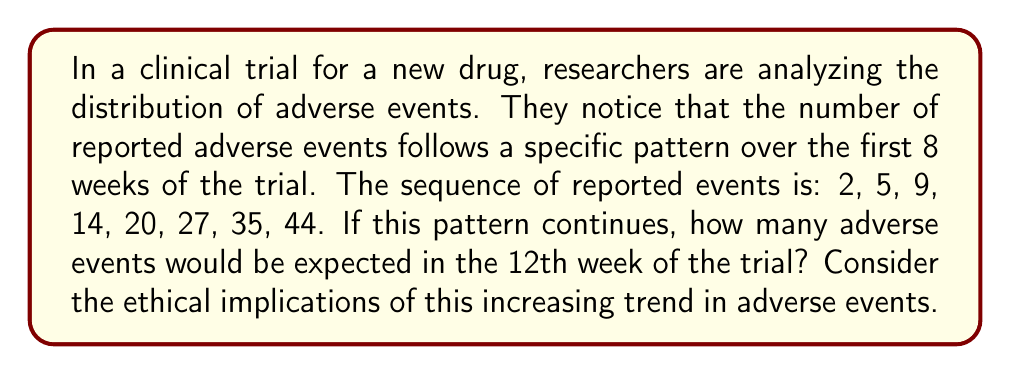Solve this math problem. To solve this problem, we need to analyze the sequence and identify the pattern:

1. First, let's calculate the differences between consecutive terms:
   $5 - 2 = 3$
   $9 - 5 = 4$
   $14 - 9 = 5$
   $20 - 14 = 6$
   $27 - 20 = 7$
   $35 - 27 = 8$
   $44 - 35 = 9$

2. We observe that the differences form an arithmetic sequence: 3, 4, 5, 6, 7, 8, 9
   The common difference of this arithmetic sequence is 1.

3. This indicates that the original sequence is a quadratic sequence, where the second differences are constant.

4. The general formula for a quadratic sequence is:
   $a_n = \frac{1}{2}n^2 + bn + c$, where $n$ is the term number.

5. We can use the first term to find $c$:
   $2 = \frac{1}{2}(1)^2 + b(1) + c$
   $2 = \frac{1}{2} + b + c$

6. Using the second term:
   $5 = \frac{1}{2}(2)^2 + b(2) + c$
   $5 = 2 + 2b + c$

7. Subtracting the equation in step 5 from the equation in step 6:
   $3 = \frac{3}{2} + b$
   $b = \frac{3}{2}$

8. Substituting back into the equation from step 5:
   $2 = \frac{1}{2} + \frac{3}{2} + c$
   $c = 0$

9. Therefore, the general formula for this sequence is:
   $a_n = \frac{1}{2}n^2 + \frac{3}{2}n$

10. To find the 12th term, we substitute $n = 12$:
    $a_{12} = \frac{1}{2}(12)^2 + \frac{3}{2}(12)$
    $a_{12} = 72 + 18 = 90$

From an ethical perspective, this increasing trend in adverse events raises concerns about the safety of the drug and the well-being of trial participants. It may be necessary to reevaluate the risk-benefit ratio and consider early termination of the trial if the trend continues.
Answer: 90 